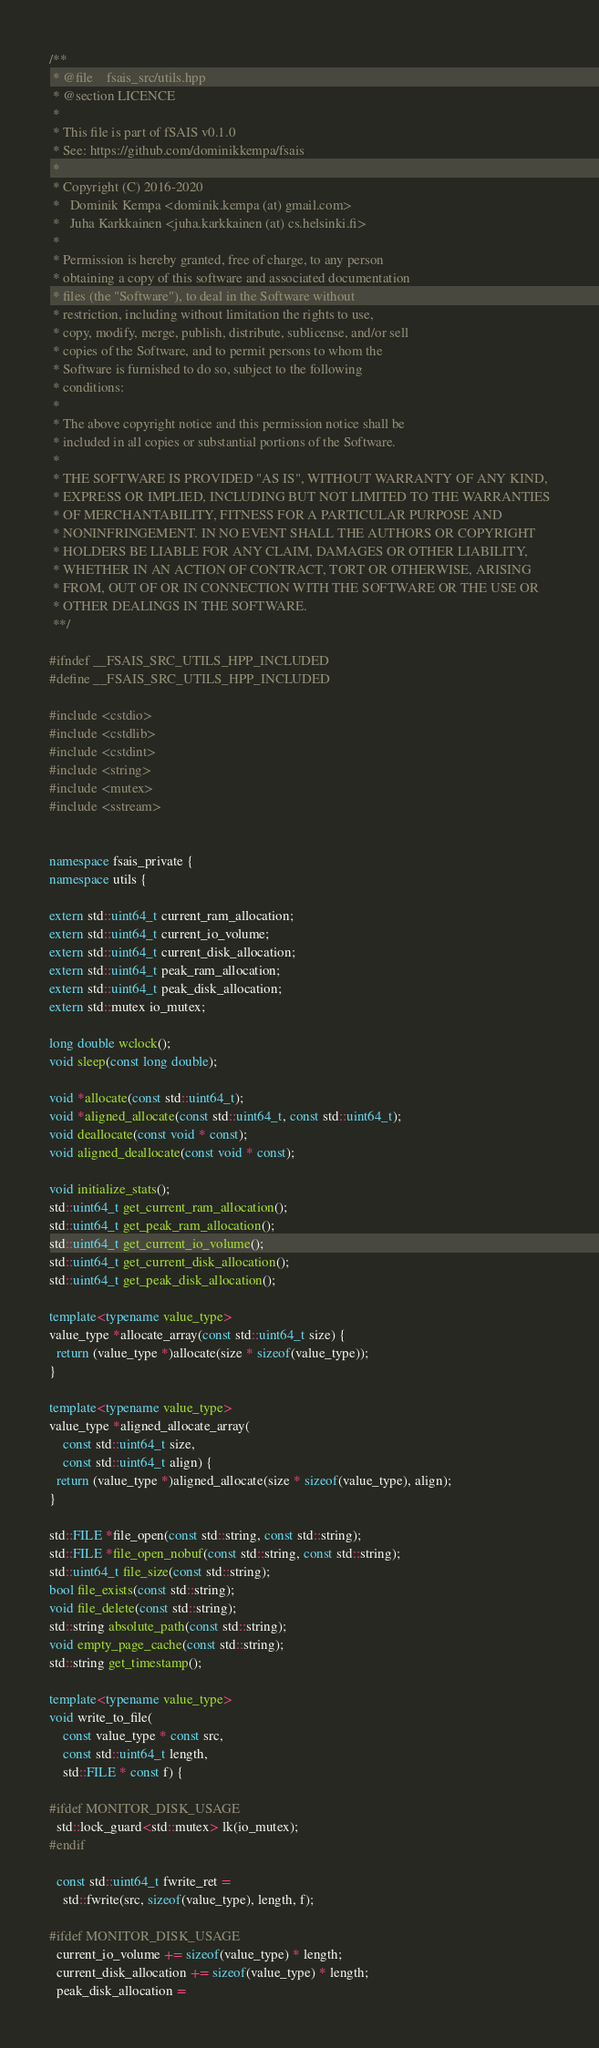<code> <loc_0><loc_0><loc_500><loc_500><_C++_>/**
 * @file    fsais_src/utils.hpp
 * @section LICENCE
 *
 * This file is part of fSAIS v0.1.0
 * See: https://github.com/dominikkempa/fsais
 *
 * Copyright (C) 2016-2020
 *   Dominik Kempa <dominik.kempa (at) gmail.com>
 *   Juha Karkkainen <juha.karkkainen (at) cs.helsinki.fi>
 *
 * Permission is hereby granted, free of charge, to any person
 * obtaining a copy of this software and associated documentation
 * files (the "Software"), to deal in the Software without
 * restriction, including without limitation the rights to use,
 * copy, modify, merge, publish, distribute, sublicense, and/or sell
 * copies of the Software, and to permit persons to whom the
 * Software is furnished to do so, subject to the following
 * conditions:
 *
 * The above copyright notice and this permission notice shall be
 * included in all copies or substantial portions of the Software.
 *
 * THE SOFTWARE IS PROVIDED "AS IS", WITHOUT WARRANTY OF ANY KIND,
 * EXPRESS OR IMPLIED, INCLUDING BUT NOT LIMITED TO THE WARRANTIES
 * OF MERCHANTABILITY, FITNESS FOR A PARTICULAR PURPOSE AND
 * NONINFRINGEMENT. IN NO EVENT SHALL THE AUTHORS OR COPYRIGHT
 * HOLDERS BE LIABLE FOR ANY CLAIM, DAMAGES OR OTHER LIABILITY,
 * WHETHER IN AN ACTION OF CONTRACT, TORT OR OTHERWISE, ARISING
 * FROM, OUT OF OR IN CONNECTION WITH THE SOFTWARE OR THE USE OR
 * OTHER DEALINGS IN THE SOFTWARE.
 **/

#ifndef __FSAIS_SRC_UTILS_HPP_INCLUDED
#define __FSAIS_SRC_UTILS_HPP_INCLUDED

#include <cstdio>
#include <cstdlib>
#include <cstdint>
#include <string>
#include <mutex>
#include <sstream>


namespace fsais_private {
namespace utils {

extern std::uint64_t current_ram_allocation;
extern std::uint64_t current_io_volume;
extern std::uint64_t current_disk_allocation;
extern std::uint64_t peak_ram_allocation;
extern std::uint64_t peak_disk_allocation;
extern std::mutex io_mutex;

long double wclock();
void sleep(const long double);

void *allocate(const std::uint64_t);
void *aligned_allocate(const std::uint64_t, const std::uint64_t);
void deallocate(const void * const);
void aligned_deallocate(const void * const);

void initialize_stats();
std::uint64_t get_current_ram_allocation();
std::uint64_t get_peak_ram_allocation();
std::uint64_t get_current_io_volume();
std::uint64_t get_current_disk_allocation();
std::uint64_t get_peak_disk_allocation();

template<typename value_type>
value_type *allocate_array(const std::uint64_t size) {
  return (value_type *)allocate(size * sizeof(value_type));
}

template<typename value_type>
value_type *aligned_allocate_array(
    const std::uint64_t size,
    const std::uint64_t align) {
  return (value_type *)aligned_allocate(size * sizeof(value_type), align);
}

std::FILE *file_open(const std::string, const std::string);
std::FILE *file_open_nobuf(const std::string, const std::string);
std::uint64_t file_size(const std::string);
bool file_exists(const std::string);
void file_delete(const std::string);
std::string absolute_path(const std::string);
void empty_page_cache(const std::string);
std::string get_timestamp();

template<typename value_type>
void write_to_file(
    const value_type * const src,
    const std::uint64_t length,
    std::FILE * const f) {

#ifdef MONITOR_DISK_USAGE
  std::lock_guard<std::mutex> lk(io_mutex);
#endif

  const std::uint64_t fwrite_ret =
    std::fwrite(src, sizeof(value_type), length, f);

#ifdef MONITOR_DISK_USAGE
  current_io_volume += sizeof(value_type) * length;
  current_disk_allocation += sizeof(value_type) * length;
  peak_disk_allocation =</code> 